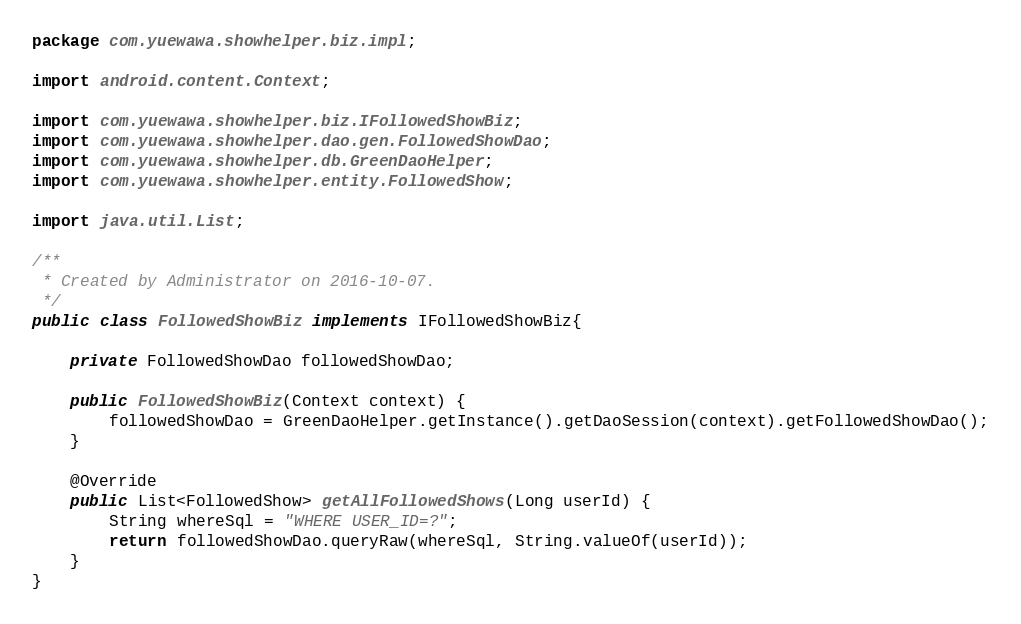Convert code to text. <code><loc_0><loc_0><loc_500><loc_500><_Java_>package com.yuewawa.showhelper.biz.impl;

import android.content.Context;

import com.yuewawa.showhelper.biz.IFollowedShowBiz;
import com.yuewawa.showhelper.dao.gen.FollowedShowDao;
import com.yuewawa.showhelper.db.GreenDaoHelper;
import com.yuewawa.showhelper.entity.FollowedShow;

import java.util.List;

/**
 * Created by Administrator on 2016-10-07.
 */
public class FollowedShowBiz implements IFollowedShowBiz{

    private FollowedShowDao followedShowDao;

    public FollowedShowBiz(Context context) {
        followedShowDao = GreenDaoHelper.getInstance().getDaoSession(context).getFollowedShowDao();
    }

    @Override
    public List<FollowedShow> getAllFollowedShows(Long userId) {
        String whereSql = "WHERE USER_ID=?";
        return followedShowDao.queryRaw(whereSql, String.valueOf(userId));
    }
}
</code> 